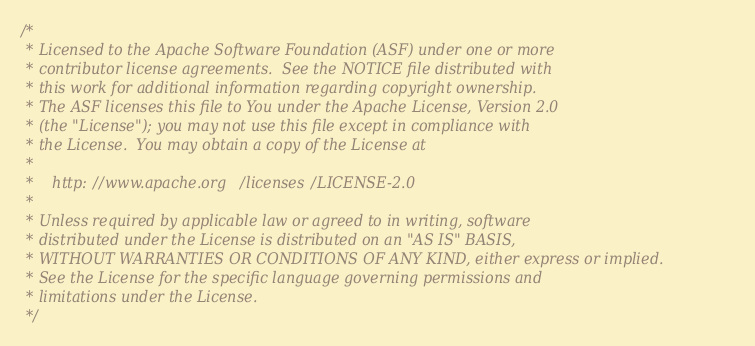<code> <loc_0><loc_0><loc_500><loc_500><_Scala_>/*
 * Licensed to the Apache Software Foundation (ASF) under one or more
 * contributor license agreements.  See the NOTICE file distributed with
 * this work for additional information regarding copyright ownership.
 * The ASF licenses this file to You under the Apache License, Version 2.0
 * (the "License"); you may not use this file except in compliance with
 * the License.  You may obtain a copy of the License at
 *
 *    http://www.apache.org/licenses/LICENSE-2.0
 *
 * Unless required by applicable law or agreed to in writing, software
 * distributed under the License is distributed on an "AS IS" BASIS,
 * WITHOUT WARRANTIES OR CONDITIONS OF ANY KIND, either express or implied.
 * See the License for the specific language governing permissions and
 * limitations under the License.
 */
</code> 